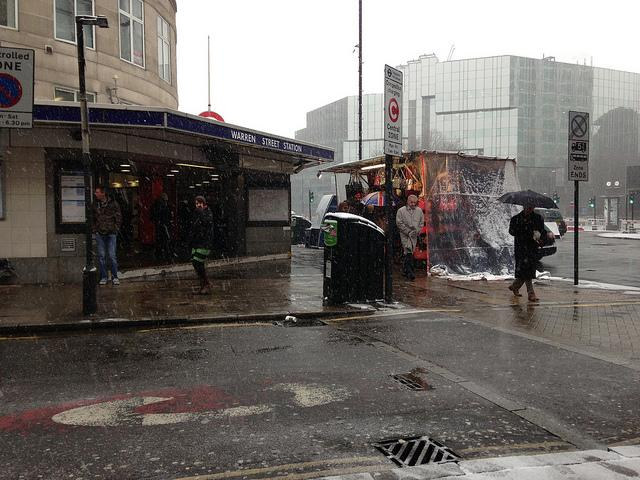What does the item the person on the far right is holding protect against? rain 